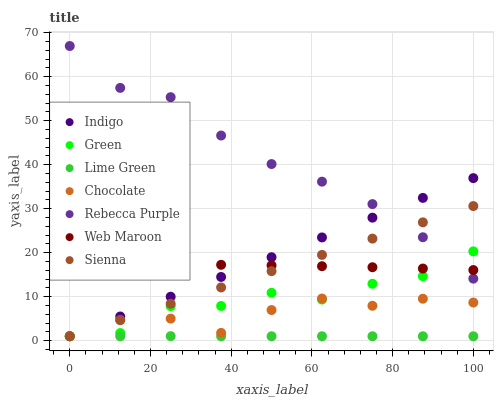Does Lime Green have the minimum area under the curve?
Answer yes or no. Yes. Does Rebecca Purple have the maximum area under the curve?
Answer yes or no. Yes. Does Web Maroon have the minimum area under the curve?
Answer yes or no. No. Does Web Maroon have the maximum area under the curve?
Answer yes or no. No. Is Indigo the smoothest?
Answer yes or no. Yes. Is Green the roughest?
Answer yes or no. Yes. Is Web Maroon the smoothest?
Answer yes or no. No. Is Web Maroon the roughest?
Answer yes or no. No. Does Indigo have the lowest value?
Answer yes or no. Yes. Does Web Maroon have the lowest value?
Answer yes or no. No. Does Rebecca Purple have the highest value?
Answer yes or no. Yes. Does Web Maroon have the highest value?
Answer yes or no. No. Is Lime Green less than Web Maroon?
Answer yes or no. Yes. Is Web Maroon greater than Lime Green?
Answer yes or no. Yes. Does Web Maroon intersect Green?
Answer yes or no. Yes. Is Web Maroon less than Green?
Answer yes or no. No. Is Web Maroon greater than Green?
Answer yes or no. No. Does Lime Green intersect Web Maroon?
Answer yes or no. No. 